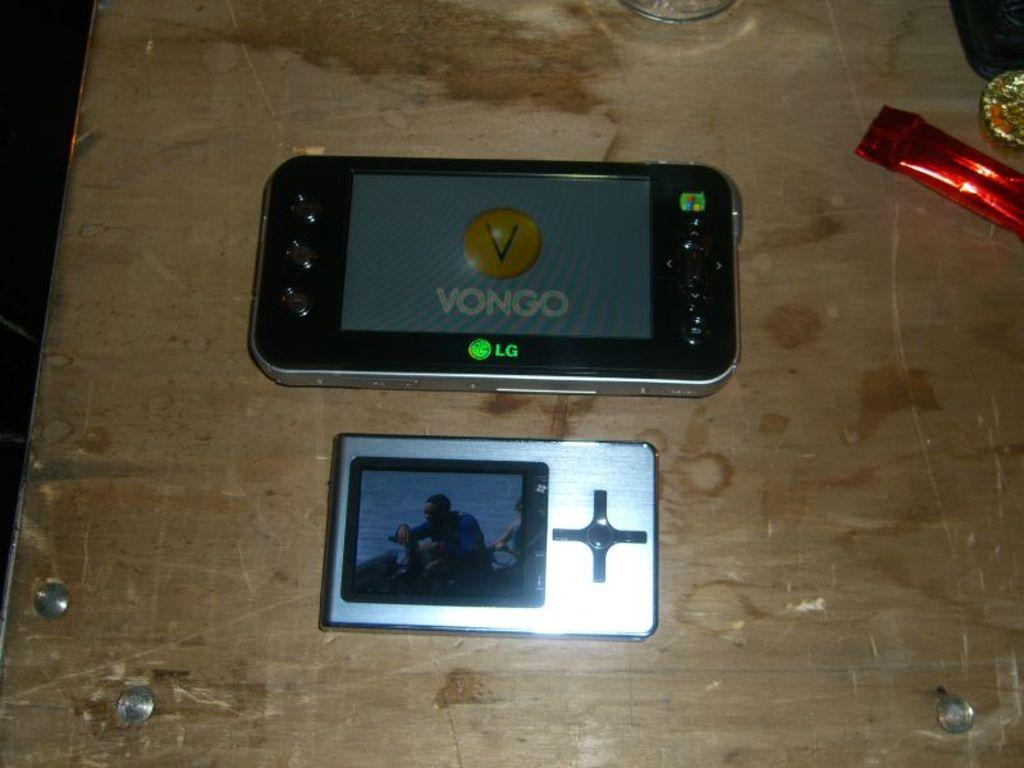What electronic device can be seen in the image? There is a mobile phone in the image. What other electronic device is present in the image? There is an iPod in the image. What type of food is visible in the image? There is chocolate in the image. What is used for drinking in the image? There is a glass in the image. What other objects can be seen on the table in the image? There are other objects on the table in the image. What type of thread is being used to sew the table in the image? There is no thread or sewing activity present in the image; it features electronic devices, chocolate, a glass, and other objects on a table. What type of plough is visible in the image? There is no plough present in the image. 